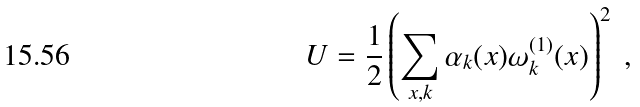Convert formula to latex. <formula><loc_0><loc_0><loc_500><loc_500>U = \frac { 1 } { 2 } \left ( \sum _ { x , k } \alpha _ { k } ( x ) \omega ^ { ( 1 ) } _ { k } ( x ) \right ) ^ { 2 } \ ,</formula> 